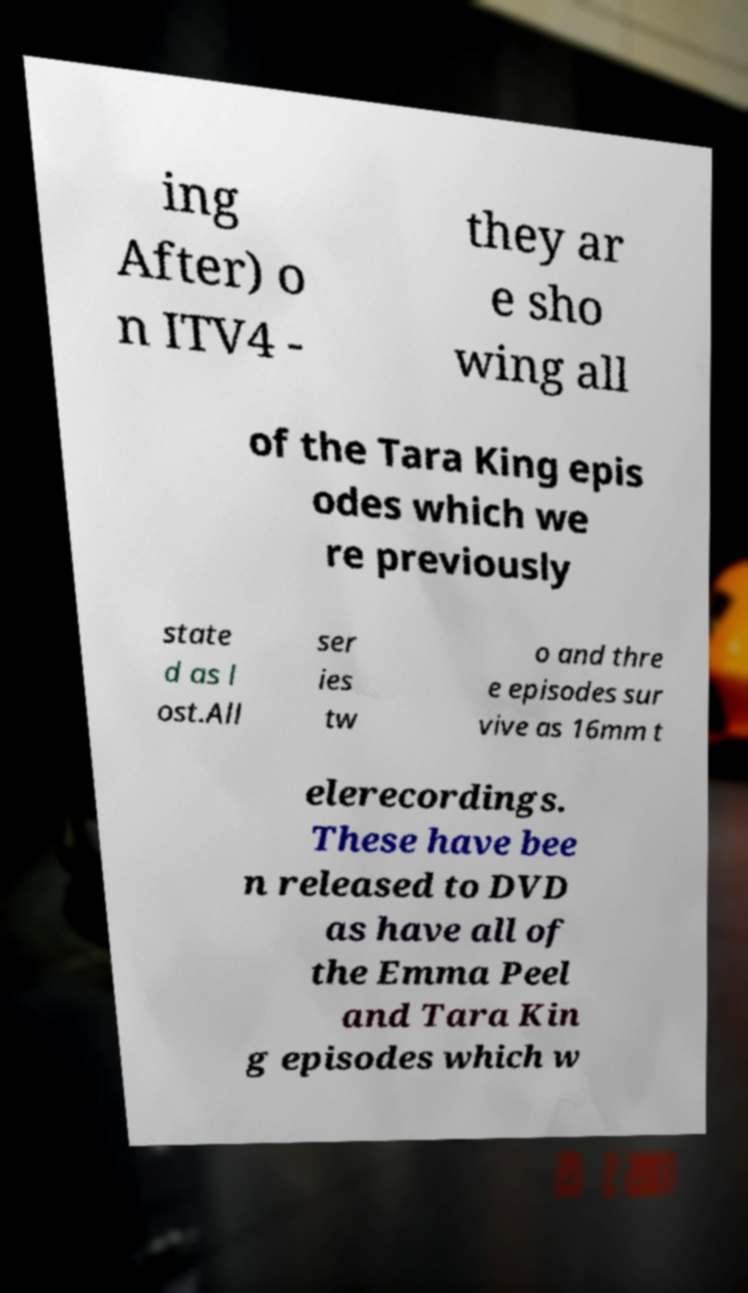Could you extract and type out the text from this image? ing After) o n ITV4 - they ar e sho wing all of the Tara King epis odes which we re previously state d as l ost.All ser ies tw o and thre e episodes sur vive as 16mm t elerecordings. These have bee n released to DVD as have all of the Emma Peel and Tara Kin g episodes which w 